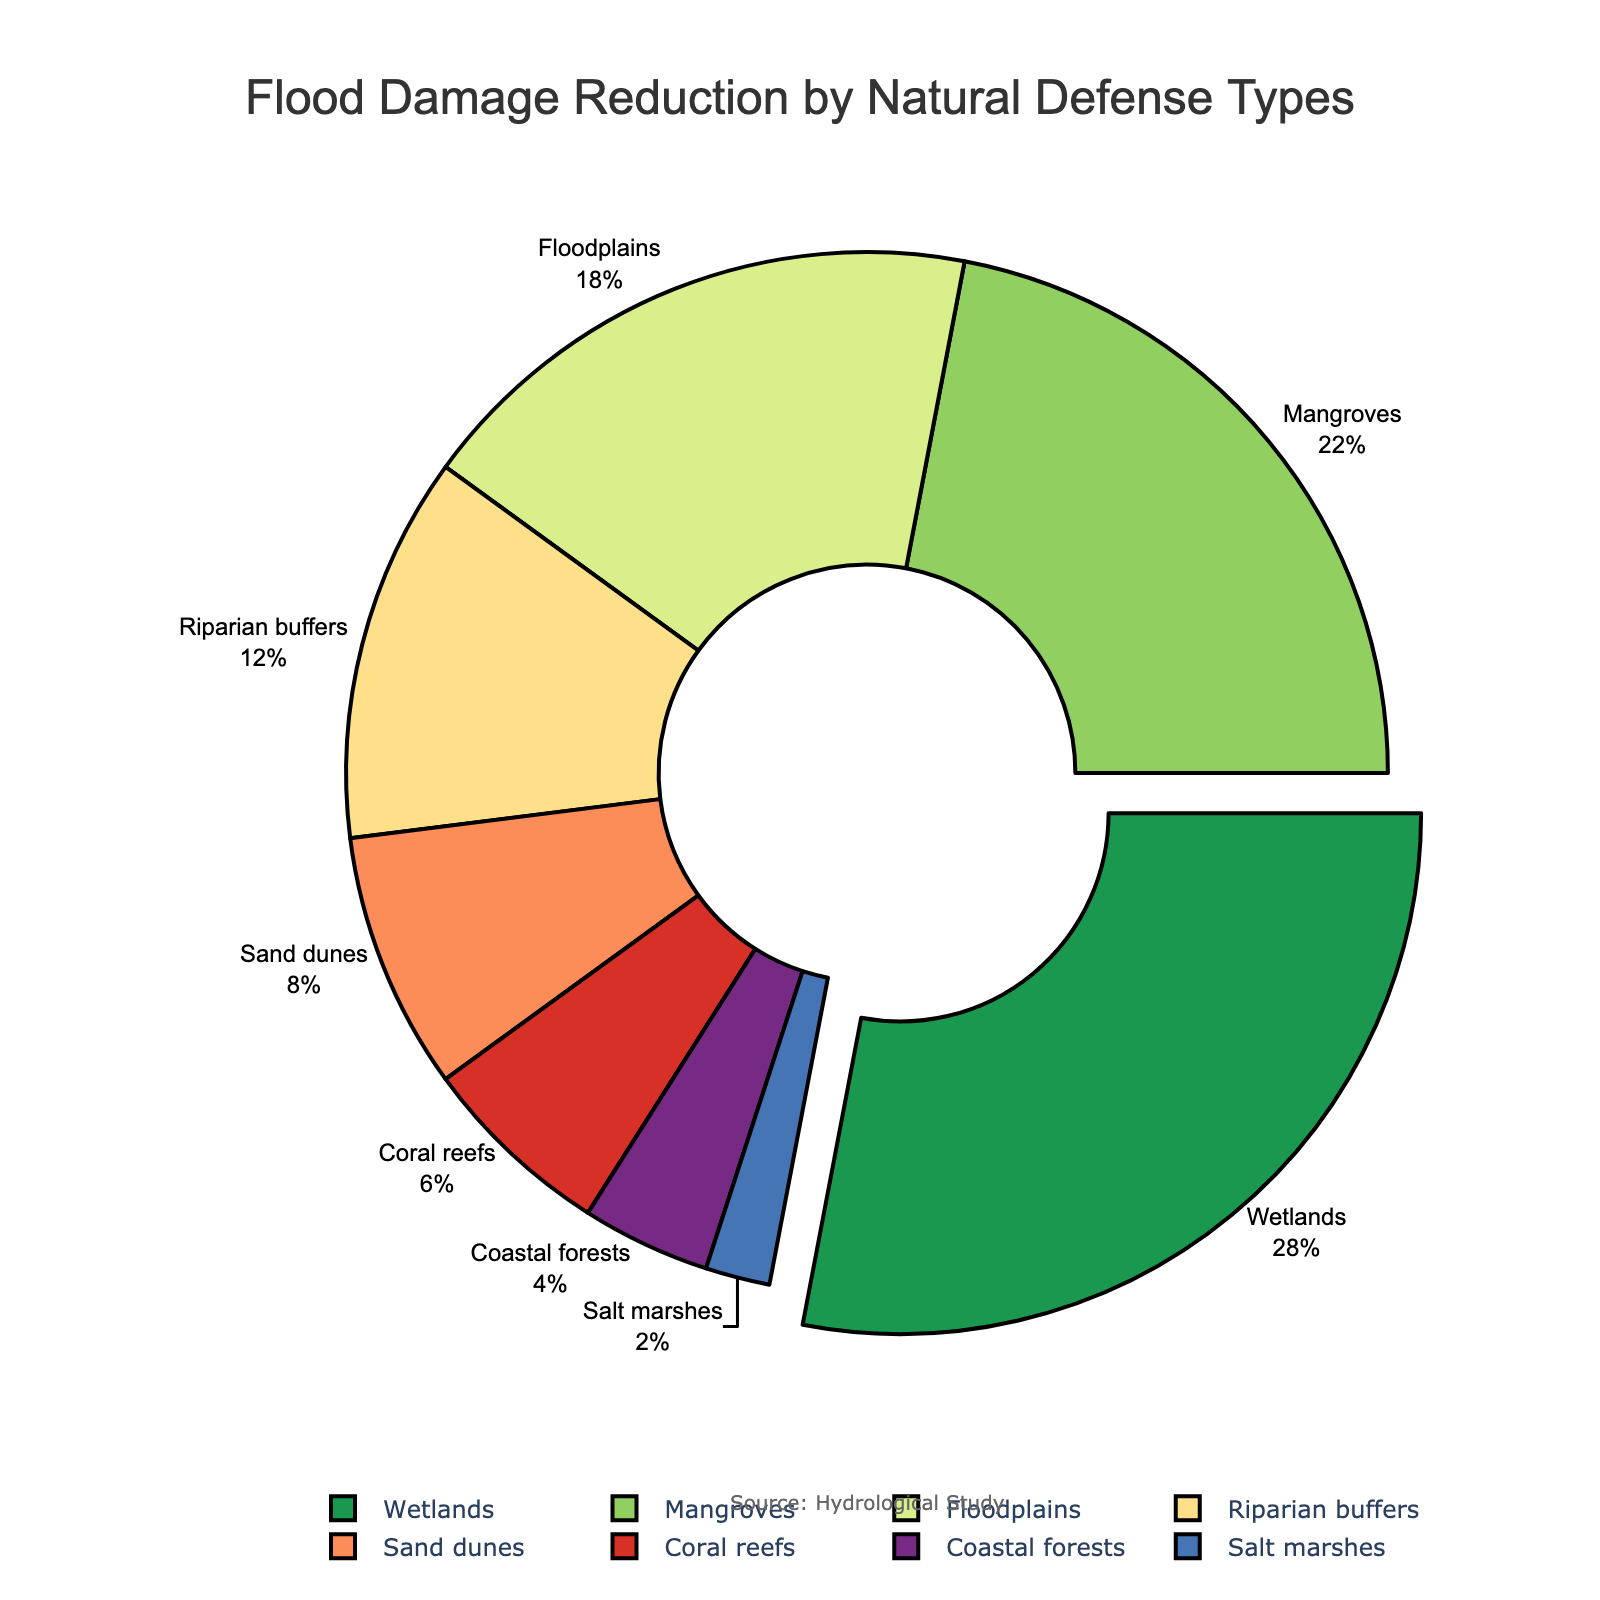Which natural defense type contributes the most to flood damage reduction? The largest segment in the pie chart is highlighted and labeled "Wetlands" with a percentage of 28%.
Answer: Wetlands What is the combined percentage of flood damage reduction provided by Mangroves and Floodplains? Add the percentages for Mangroves (22%) and Floodplains (18%). 22% + 18% = 40%.
Answer: 40% Which natural defense type is represented by the smallest segment in the pie chart? The smallest segment visually corresponds to "Salt marshes," labeled with a percentage of 2%.
Answer: Salt marshes How does the percentage for Sand dunes compare to Coral reefs? Sand dunes contribute 8%, and Coral reefs contribute 6%. By comparing these values, Sand dunes provide a greater percentage than Coral reefs.
Answer: Sand dunes provide more than Coral reefs What is the difference in percentage between the contribution of Wetlands and Coastal forests? The percentage for Wetlands is 28% and for Coastal forests is 4%. Subtract the smaller percentage from the larger one: 28% - 4% = 24%.
Answer: 24% What is the percentage contribution of Riparian buffers, and how does it visually compare to that of Mangroves? Riparian buffers have a percentage of 12%, and Mangroves have a percentage of 22%. Mangroves visually occupy a larger portion of the pie chart by 10%.
Answer: Riparian buffers have 12%, less than Mangroves by 10% If you combine the percentage contributions of the four smallest natural defense types, what is their total? The four smallest segments are Salt marshes (2%), Coastal forests (4%), Coral reefs (6%), and Sand dunes (8%). Adding these percentages: 2% + 4% + 6% + 8% = 20%.
Answer: 20% 